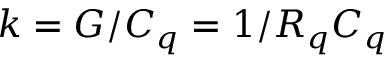<formula> <loc_0><loc_0><loc_500><loc_500>k = G / C _ { q } = 1 / R _ { q } C _ { q }</formula> 